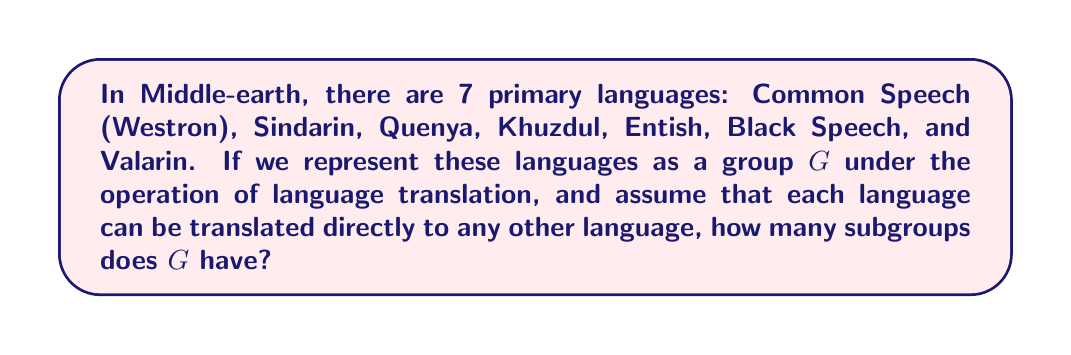Can you answer this question? Let's approach this step-by-step:

1) First, we need to recognize that this group is isomorphic to the symmetric group $S_7$, as each language can be "permuted" or translated to any other language.

2) The number of subgroups of $S_n$ is known as the subgroup growth function, denoted as $s(S_n)$.

3) For $S_7$, the exact value of $s(S_7)$ is known. It can be calculated using advanced group theory techniques, but the result is:

   $s(S_7) = 1,784,243,745$

4) To understand this number, let's break it down:
   - There are subgroups of order 1 (the trivial subgroup)
   - Subgroups of prime order (2, 3, 5, 7)
   - Subgroups of composite order (4, 6, 8, 9, 10, 12, 14, 15, 16, 18, 20, 21, 24, 28, 30, 35, 36, 42, 48, 56, 60, 72, 84, 120, 168, 210, 240, 360, 420, 720, 5040)

5) Each of these subgroups represents a subset of languages that can be translated among themselves. For example:
   - A subgroup of order 2 might represent the ability to translate between Westron and Sindarin only.
   - A subgroup of order 7 (the whole group) represents the ability to translate between all languages.

6) The large number of subgroups reflects the complexity and richness of Middle-earth's linguistic landscape, much like the intricate world-building in Tolkien's works.
Answer: The group $G$ representing the languages of Middle-earth has $1,784,243,745$ subgroups. 